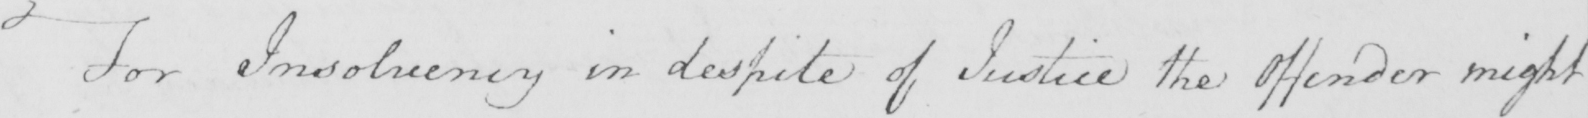What does this handwritten line say? For Insolvency in despite of Justice the Offender might 